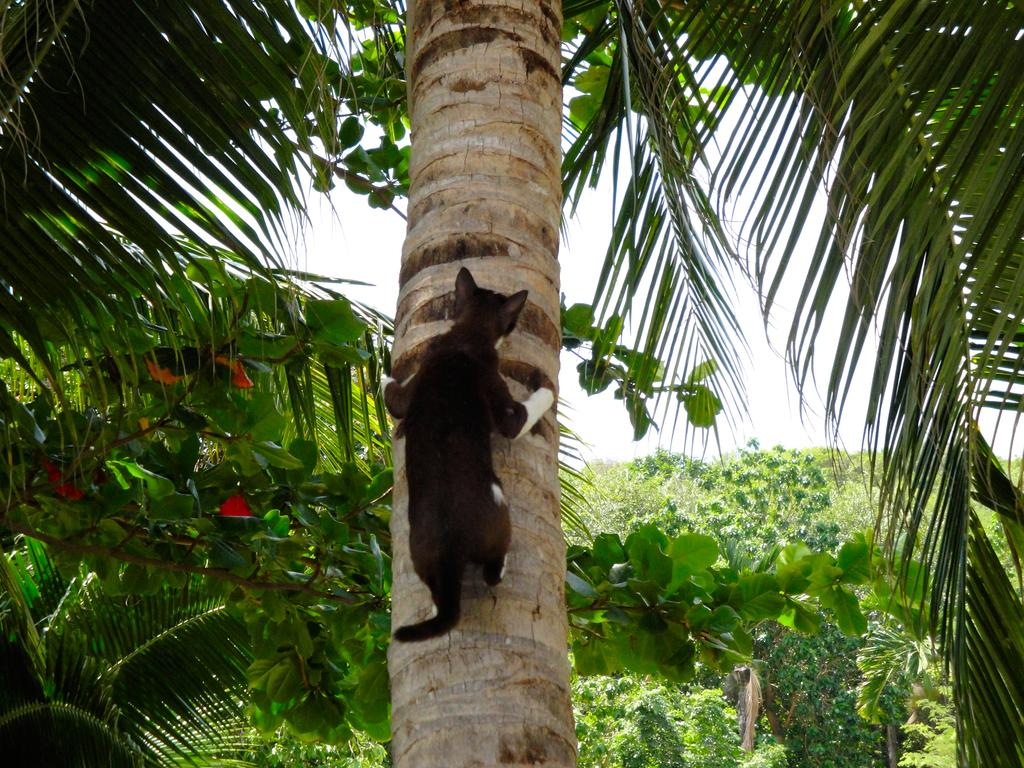What animal is present in the image? There is a cat in the image. Where is the cat located? The cat is on a tree. What can be seen in the background of the image? There are trees and the sky visible in the background of the image. How many wheels can be seen on the cat in the image? There are no wheels present on the cat in the image, as cats do not have wheels. 